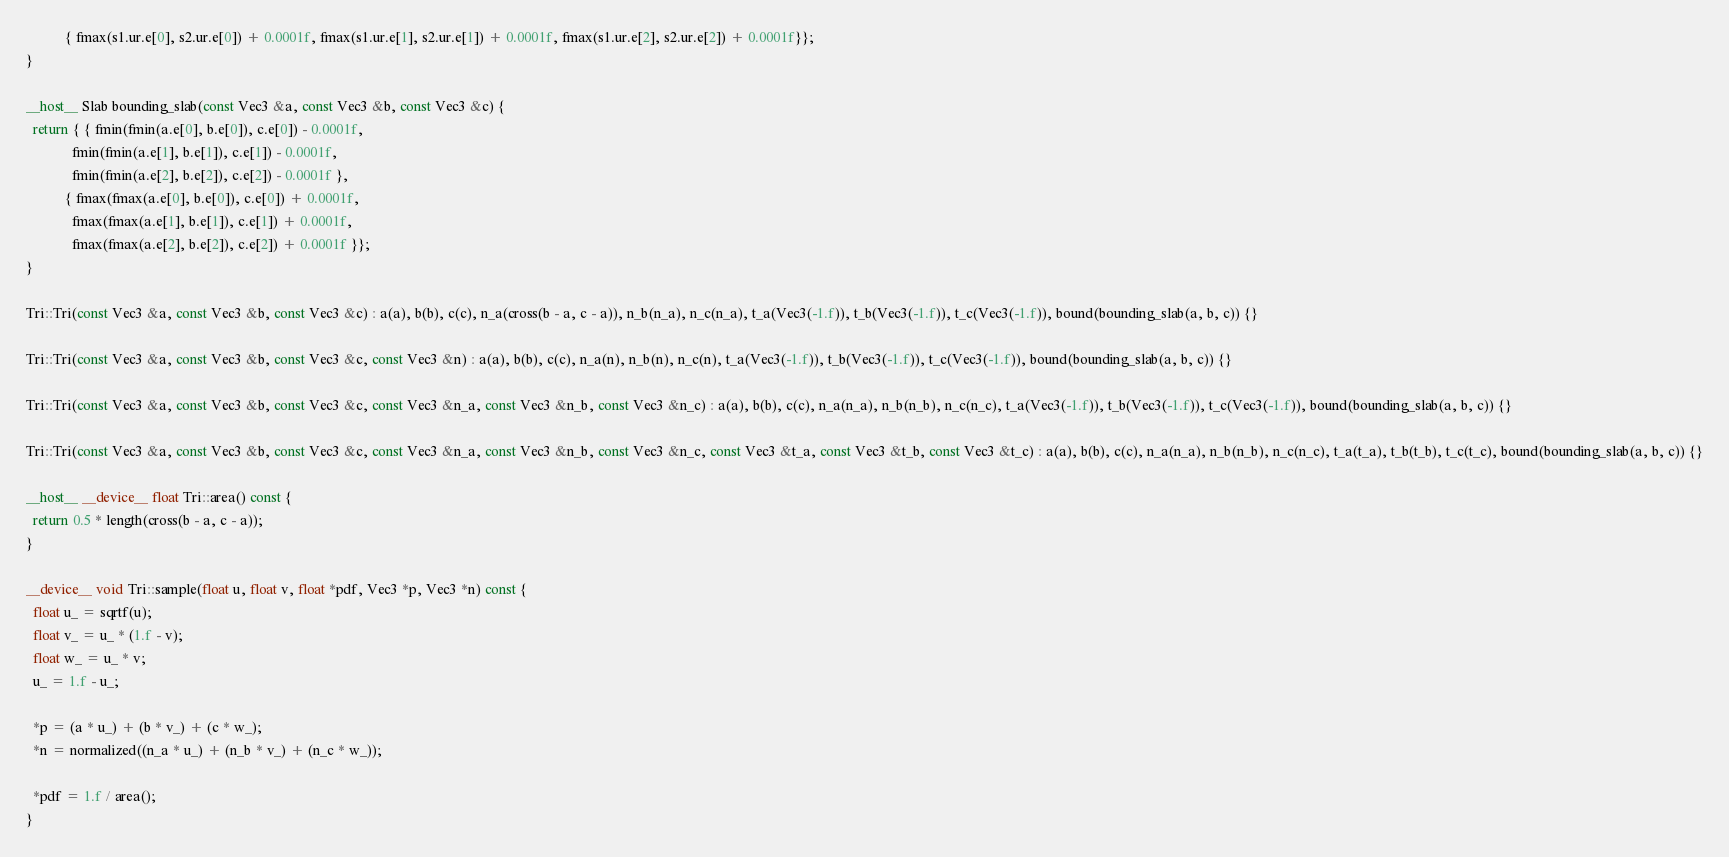<code> <loc_0><loc_0><loc_500><loc_500><_Cuda_>           { fmax(s1.ur.e[0], s2.ur.e[0]) + 0.0001f, fmax(s1.ur.e[1], s2.ur.e[1]) + 0.0001f, fmax(s1.ur.e[2], s2.ur.e[2]) + 0.0001f}};
}

__host__ Slab bounding_slab(const Vec3 &a, const Vec3 &b, const Vec3 &c) {
  return { { fmin(fmin(a.e[0], b.e[0]), c.e[0]) - 0.0001f,
             fmin(fmin(a.e[1], b.e[1]), c.e[1]) - 0.0001f,
             fmin(fmin(a.e[2], b.e[2]), c.e[2]) - 0.0001f },
           { fmax(fmax(a.e[0], b.e[0]), c.e[0]) + 0.0001f,
             fmax(fmax(a.e[1], b.e[1]), c.e[1]) + 0.0001f,
             fmax(fmax(a.e[2], b.e[2]), c.e[2]) + 0.0001f }};
}

Tri::Tri(const Vec3 &a, const Vec3 &b, const Vec3 &c) : a(a), b(b), c(c), n_a(cross(b - a, c - a)), n_b(n_a), n_c(n_a), t_a(Vec3(-1.f)), t_b(Vec3(-1.f)), t_c(Vec3(-1.f)), bound(bounding_slab(a, b, c)) {}

Tri::Tri(const Vec3 &a, const Vec3 &b, const Vec3 &c, const Vec3 &n) : a(a), b(b), c(c), n_a(n), n_b(n), n_c(n), t_a(Vec3(-1.f)), t_b(Vec3(-1.f)), t_c(Vec3(-1.f)), bound(bounding_slab(a, b, c)) {}

Tri::Tri(const Vec3 &a, const Vec3 &b, const Vec3 &c, const Vec3 &n_a, const Vec3 &n_b, const Vec3 &n_c) : a(a), b(b), c(c), n_a(n_a), n_b(n_b), n_c(n_c), t_a(Vec3(-1.f)), t_b(Vec3(-1.f)), t_c(Vec3(-1.f)), bound(bounding_slab(a, b, c)) {}

Tri::Tri(const Vec3 &a, const Vec3 &b, const Vec3 &c, const Vec3 &n_a, const Vec3 &n_b, const Vec3 &n_c, const Vec3 &t_a, const Vec3 &t_b, const Vec3 &t_c) : a(a), b(b), c(c), n_a(n_a), n_b(n_b), n_c(n_c), t_a(t_a), t_b(t_b), t_c(t_c), bound(bounding_slab(a, b, c)) {}

__host__ __device__ float Tri::area() const {
  return 0.5 * length(cross(b - a, c - a));
}

__device__ void Tri::sample(float u, float v, float *pdf, Vec3 *p, Vec3 *n) const {
  float u_ = sqrtf(u);
  float v_ = u_ * (1.f - v);
  float w_ = u_ * v;
  u_ = 1.f - u_;

  *p = (a * u_) + (b * v_) + (c * w_);
  *n = normalized((n_a * u_) + (n_b * v_) + (n_c * w_));

  *pdf = 1.f / area();
}
</code> 